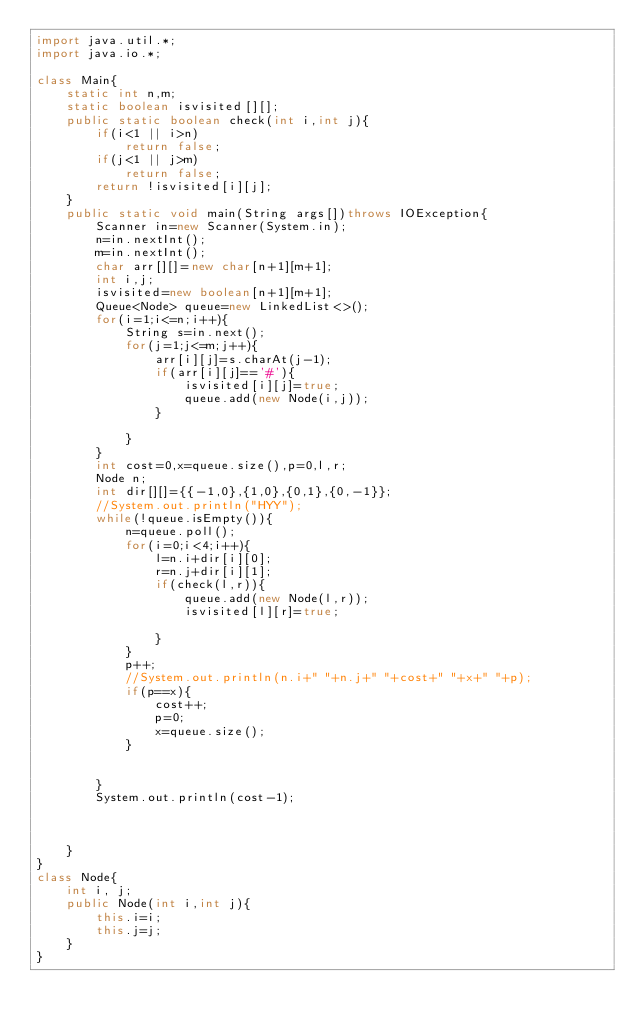Convert code to text. <code><loc_0><loc_0><loc_500><loc_500><_Java_>import java.util.*;
import java.io.*;

class Main{
    static int n,m;
    static boolean isvisited[][];
    public static boolean check(int i,int j){
        if(i<1 || i>n)
            return false;
        if(j<1 || j>m)
            return false;
        return !isvisited[i][j];
    }
    public static void main(String args[])throws IOException{
        Scanner in=new Scanner(System.in);
        n=in.nextInt();
        m=in.nextInt();
        char arr[][]=new char[n+1][m+1];
        int i,j;
        isvisited=new boolean[n+1][m+1];
        Queue<Node> queue=new LinkedList<>();
        for(i=1;i<=n;i++){
            String s=in.next();
            for(j=1;j<=m;j++){
                arr[i][j]=s.charAt(j-1);
                if(arr[i][j]=='#'){
                    isvisited[i][j]=true;
                    queue.add(new Node(i,j));
                }

            }
        }
        int cost=0,x=queue.size(),p=0,l,r;
        Node n;
        int dir[][]={{-1,0},{1,0},{0,1},{0,-1}};
        //System.out.println("HYY");
        while(!queue.isEmpty()){
            n=queue.poll();
            for(i=0;i<4;i++){
                l=n.i+dir[i][0];
                r=n.j+dir[i][1];
                if(check(l,r)){
                    queue.add(new Node(l,r));
                    isvisited[l][r]=true;

                }
            }
            p++;
            //System.out.println(n.i+" "+n.j+" "+cost+" "+x+" "+p);
            if(p==x){
                cost++;
                p=0;
                x=queue.size();
            }


        }
        System.out.println(cost-1);



    }
}
class Node{
    int i, j;
    public Node(int i,int j){
        this.i=i;
        this.j=j;
    }
}</code> 